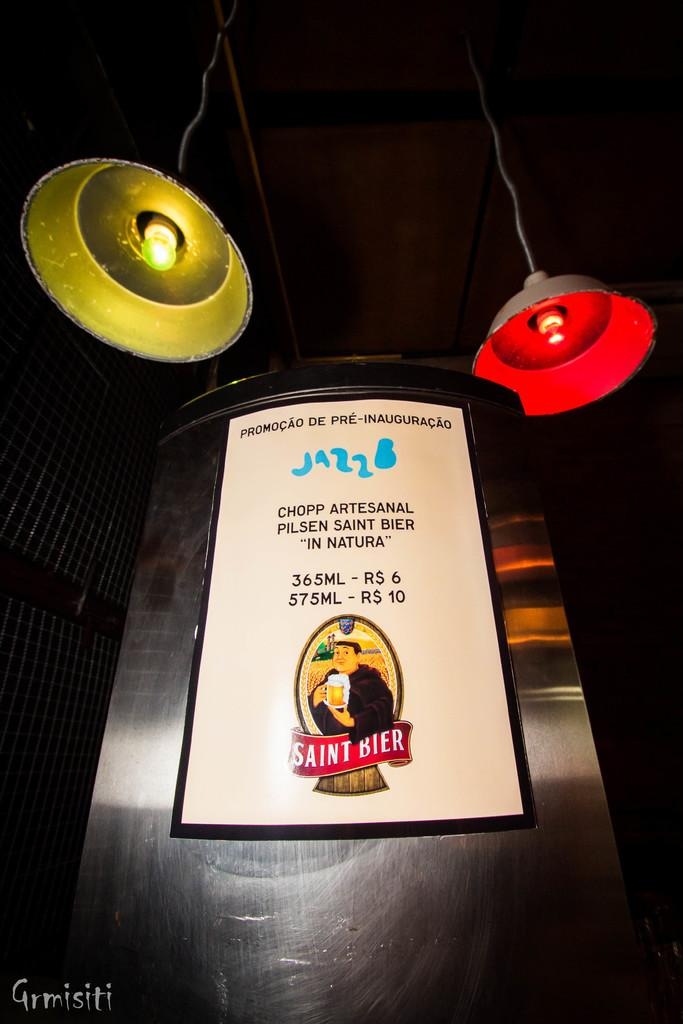<image>
Present a compact description of the photo's key features. A poster for Saint Bier hangs near some ceiling lights. 